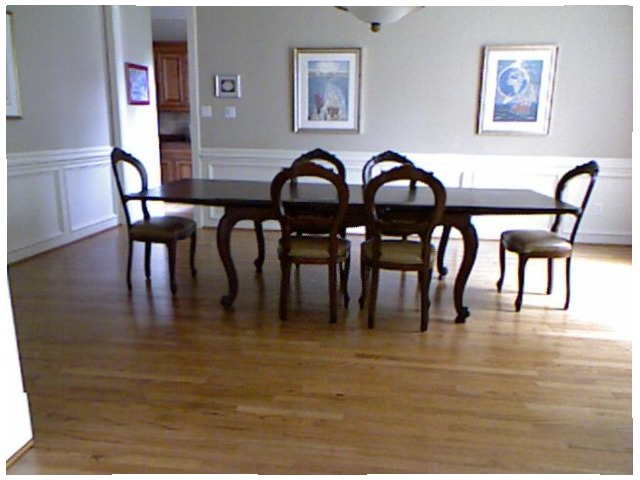<image>
Is there a chair in front of the photo? Yes. The chair is positioned in front of the photo, appearing closer to the camera viewpoint. Where is the chair in relation to the chair? Is it in front of the chair? No. The chair is not in front of the chair. The spatial positioning shows a different relationship between these objects. Where is the chandelier in relation to the dining table? Is it above the dining table? Yes. The chandelier is positioned above the dining table in the vertical space, higher up in the scene. Is there a chair on the table? No. The chair is not positioned on the table. They may be near each other, but the chair is not supported by or resting on top of the table. Where is the chair in relation to the chair? Is it to the right of the chair? No. The chair is not to the right of the chair. The horizontal positioning shows a different relationship. Is there a chair under the table? Yes. The chair is positioned underneath the table, with the table above it in the vertical space. 